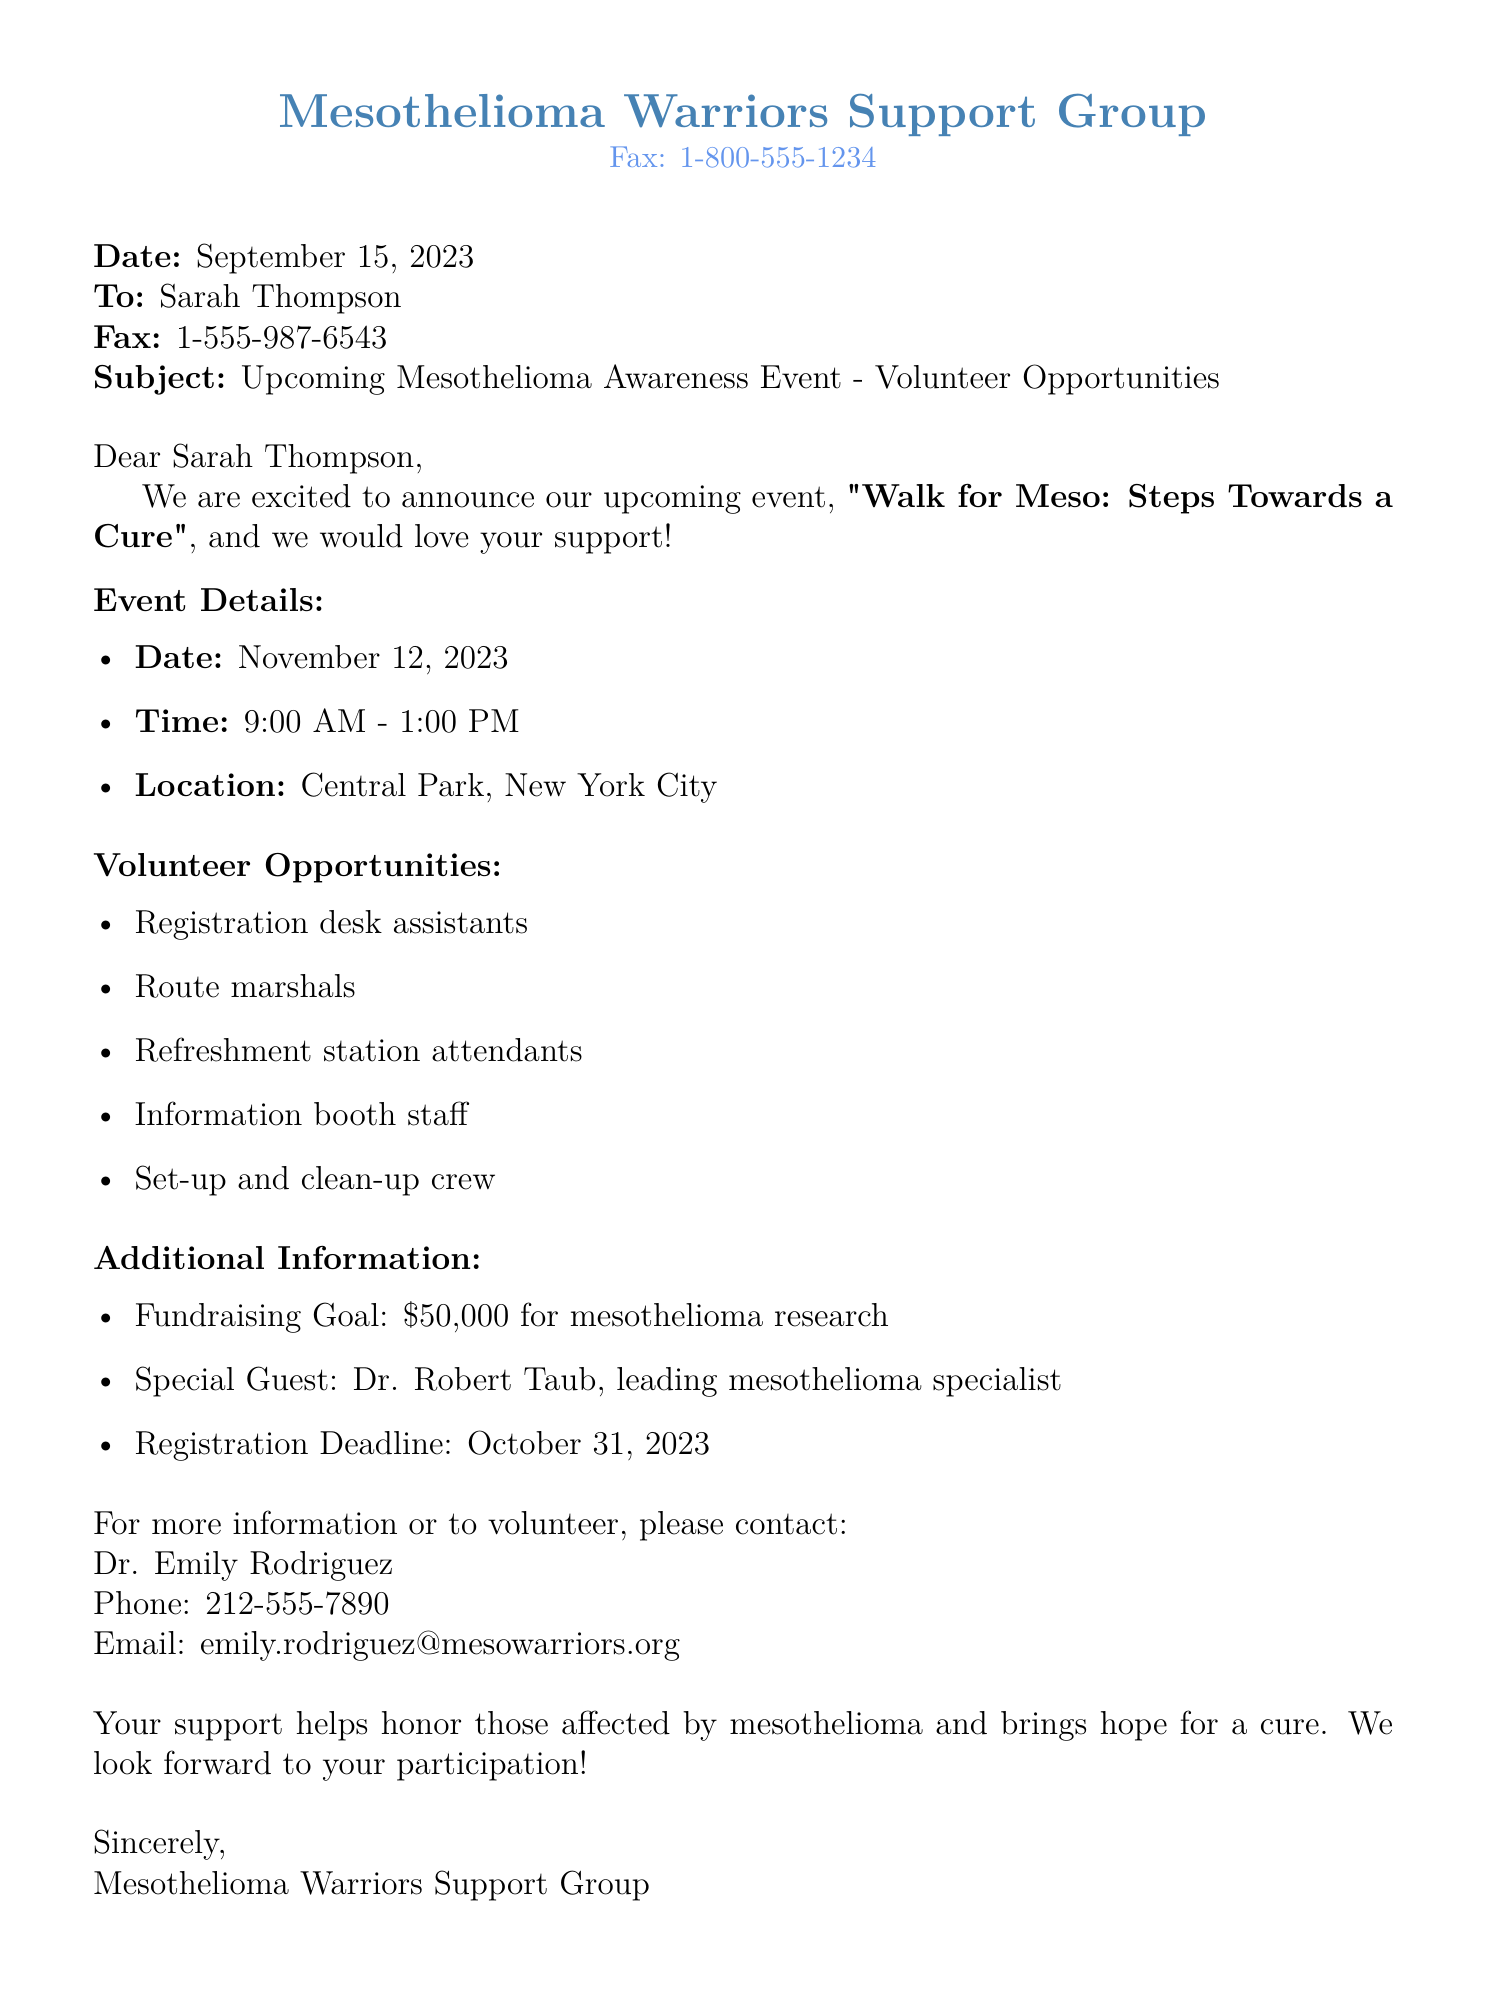What is the date of the event? The event "Walk for Meso: Steps Towards a Cure" is scheduled for November 12, 2023.
Answer: November 12, 2023 What time does the event start? The event starts at 9:00 AM and ends at 1:00 PM.
Answer: 9:00 AM Where is the event located? The event will take place at Central Park, New York City.
Answer: Central Park, New York City Who is the special guest at the event? The special guest is Dr. Robert Taub, a leading mesothelioma specialist.
Answer: Dr. Robert Taub What is the fundraising goal for the event? The fundraising goal is set at $50,000 for mesothelioma research.
Answer: $50,000 What is the registration deadline? Individuals interested in participating must register by October 31, 2023.
Answer: October 31, 2023 What types of volunteer opportunities are available? Volunteers can assist at the registration desk, as route marshals, refreshment station attendants, and more.
Answer: Registration desk assistants, route marshals, refreshment station attendants, information booth staff, set-up and clean-up crew Who should be contacted for more information? Dr. Emily Rodriguez is the contact person for more information or to volunteer.
Answer: Dr. Emily Rodriguez 